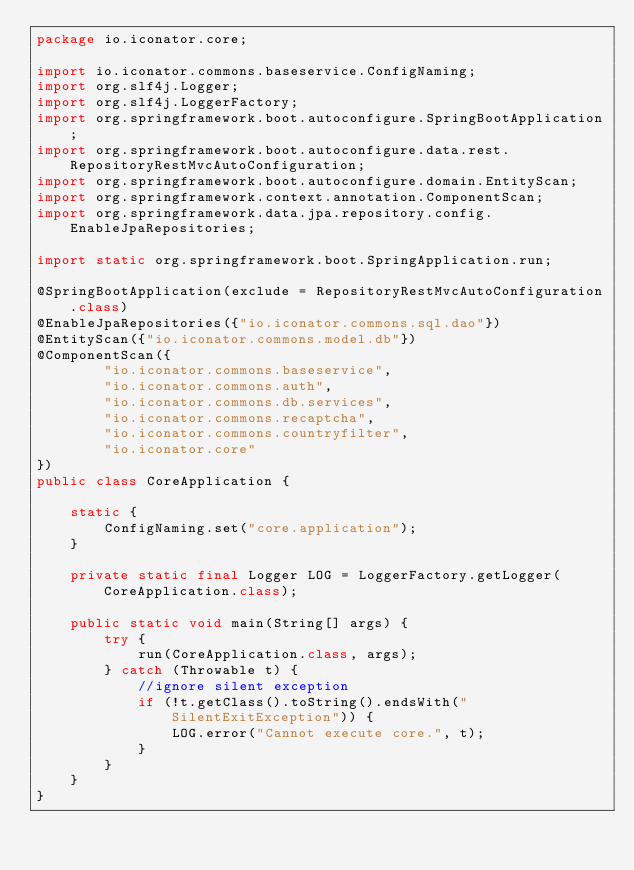<code> <loc_0><loc_0><loc_500><loc_500><_Java_>package io.iconator.core;

import io.iconator.commons.baseservice.ConfigNaming;
import org.slf4j.Logger;
import org.slf4j.LoggerFactory;
import org.springframework.boot.autoconfigure.SpringBootApplication;
import org.springframework.boot.autoconfigure.data.rest.RepositoryRestMvcAutoConfiguration;
import org.springframework.boot.autoconfigure.domain.EntityScan;
import org.springframework.context.annotation.ComponentScan;
import org.springframework.data.jpa.repository.config.EnableJpaRepositories;

import static org.springframework.boot.SpringApplication.run;

@SpringBootApplication(exclude = RepositoryRestMvcAutoConfiguration.class)
@EnableJpaRepositories({"io.iconator.commons.sql.dao"})
@EntityScan({"io.iconator.commons.model.db"})
@ComponentScan({
        "io.iconator.commons.baseservice",
        "io.iconator.commons.auth",
        "io.iconator.commons.db.services",
        "io.iconator.commons.recaptcha",
        "io.iconator.commons.countryfilter",
        "io.iconator.core"
})
public class CoreApplication {

    static {
        ConfigNaming.set("core.application");
    }

    private static final Logger LOG = LoggerFactory.getLogger(CoreApplication.class);

    public static void main(String[] args) {
        try {
            run(CoreApplication.class, args);
        } catch (Throwable t) {
            //ignore silent exception
            if (!t.getClass().toString().endsWith("SilentExitException")) {
                LOG.error("Cannot execute core.", t);
            }
        }
    }
}
</code> 